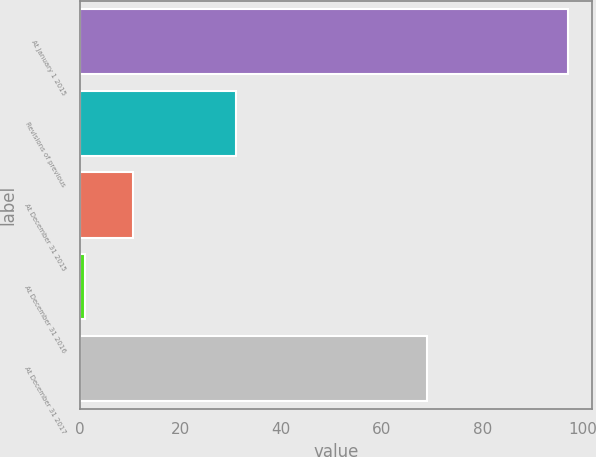<chart> <loc_0><loc_0><loc_500><loc_500><bar_chart><fcel>At January 1 2015<fcel>Revisions of previous<fcel>At December 31 2015<fcel>At December 31 2016<fcel>At December 31 2017<nl><fcel>97<fcel>31<fcel>10.6<fcel>1<fcel>69<nl></chart> 